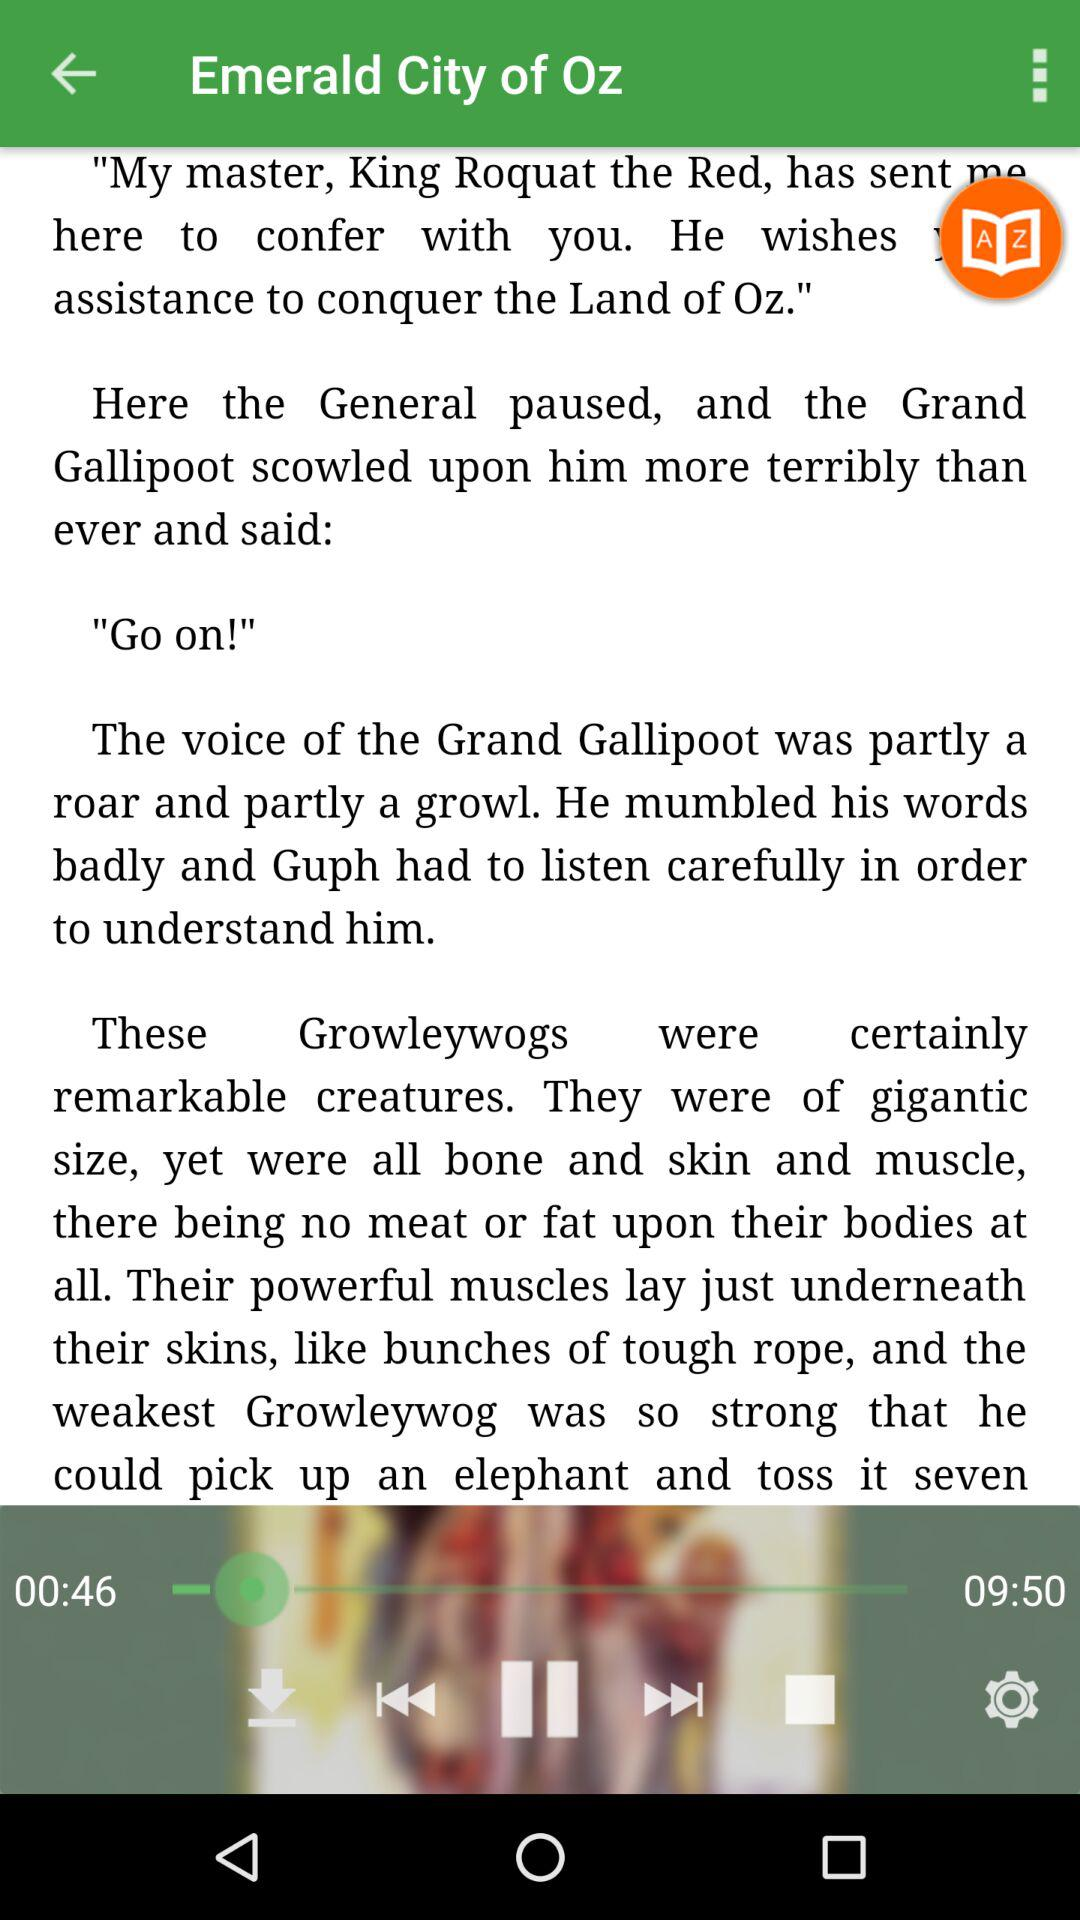What is the total duration of the audio? The total duration of the audio is 9 minutes 50 seconds. 